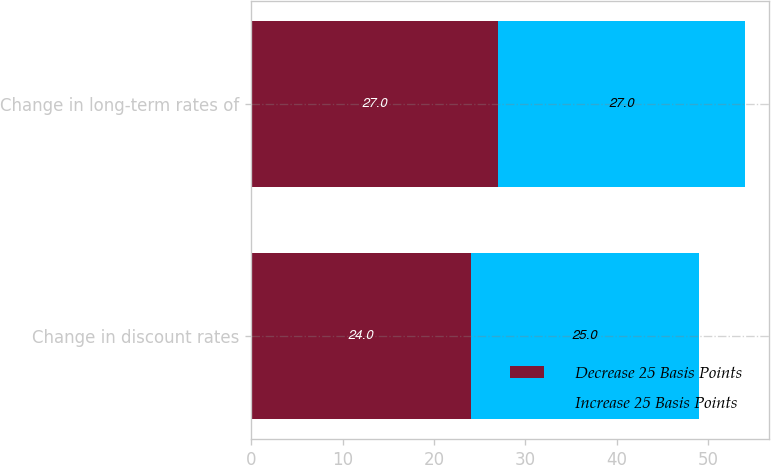<chart> <loc_0><loc_0><loc_500><loc_500><stacked_bar_chart><ecel><fcel>Change in discount rates<fcel>Change in long-term rates of<nl><fcel>Decrease 25 Basis Points<fcel>24<fcel>27<nl><fcel>Increase 25 Basis Points<fcel>25<fcel>27<nl></chart> 